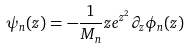<formula> <loc_0><loc_0><loc_500><loc_500>\psi _ { n } ( z ) = - \frac { 1 } { M _ { n } } z e ^ { z ^ { 2 } } \partial _ { z } \phi _ { n } ( z )</formula> 